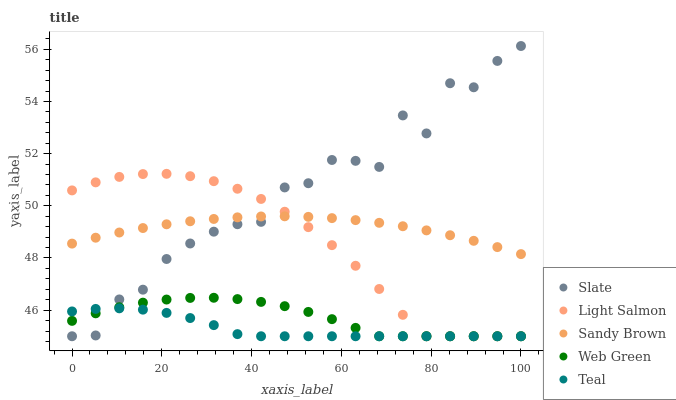Does Teal have the minimum area under the curve?
Answer yes or no. Yes. Does Slate have the maximum area under the curve?
Answer yes or no. Yes. Does Sandy Brown have the minimum area under the curve?
Answer yes or no. No. Does Sandy Brown have the maximum area under the curve?
Answer yes or no. No. Is Sandy Brown the smoothest?
Answer yes or no. Yes. Is Slate the roughest?
Answer yes or no. Yes. Is Slate the smoothest?
Answer yes or no. No. Is Sandy Brown the roughest?
Answer yes or no. No. Does Teal have the lowest value?
Answer yes or no. Yes. Does Sandy Brown have the lowest value?
Answer yes or no. No. Does Slate have the highest value?
Answer yes or no. Yes. Does Sandy Brown have the highest value?
Answer yes or no. No. Is Teal less than Sandy Brown?
Answer yes or no. Yes. Is Sandy Brown greater than Teal?
Answer yes or no. Yes. Does Light Salmon intersect Teal?
Answer yes or no. Yes. Is Light Salmon less than Teal?
Answer yes or no. No. Is Light Salmon greater than Teal?
Answer yes or no. No. Does Teal intersect Sandy Brown?
Answer yes or no. No. 